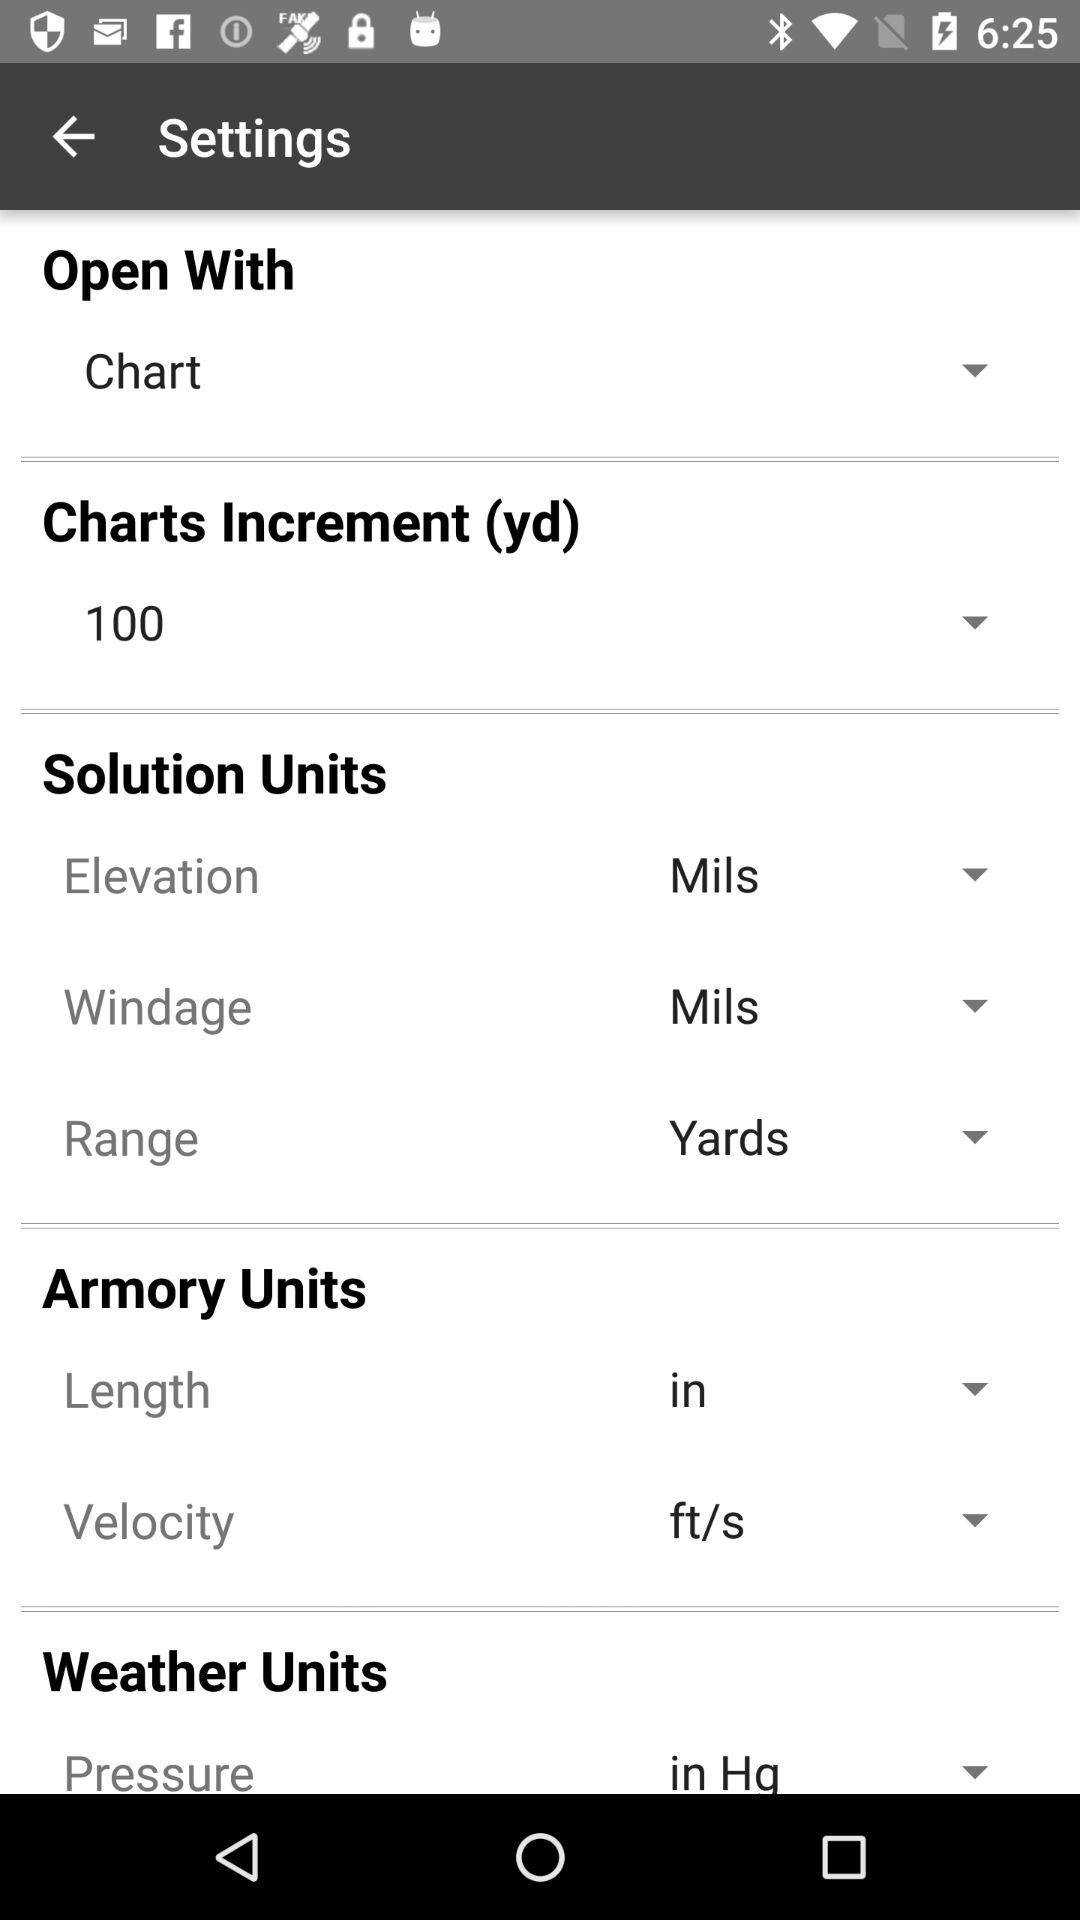Which length is selected? The selected length is "in". 